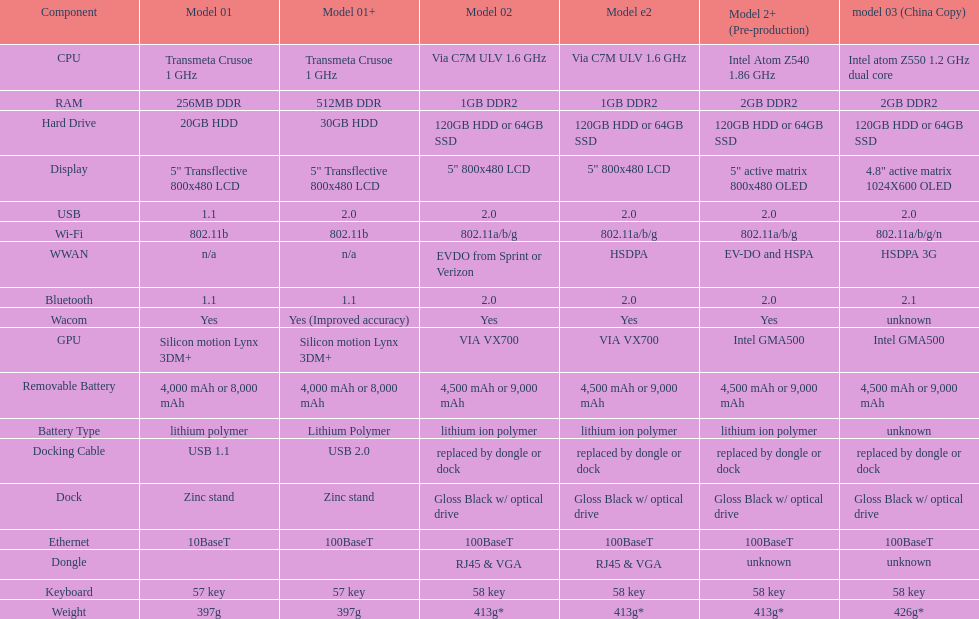How many models feature 2. 